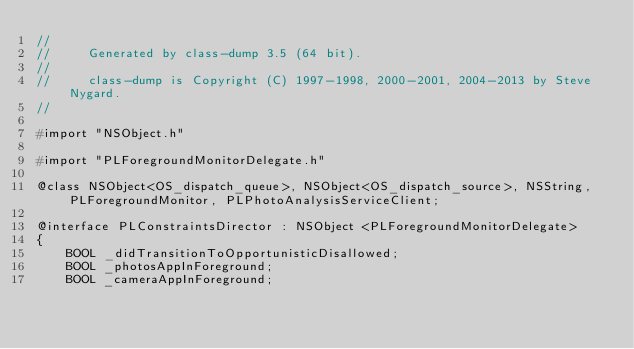Convert code to text. <code><loc_0><loc_0><loc_500><loc_500><_C_>//
//     Generated by class-dump 3.5 (64 bit).
//
//     class-dump is Copyright (C) 1997-1998, 2000-2001, 2004-2013 by Steve Nygard.
//

#import "NSObject.h"

#import "PLForegroundMonitorDelegate.h"

@class NSObject<OS_dispatch_queue>, NSObject<OS_dispatch_source>, NSString, PLForegroundMonitor, PLPhotoAnalysisServiceClient;

@interface PLConstraintsDirector : NSObject <PLForegroundMonitorDelegate>
{
    BOOL _didTransitionToOpportunisticDisallowed;
    BOOL _photosAppInForeground;
    BOOL _cameraAppInForeground;</code> 